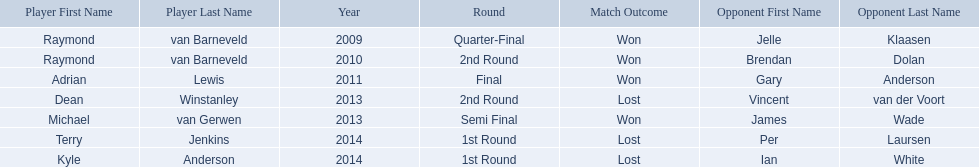What players competed in the pdc world darts championship? Raymond van Barneveld, Raymond van Barneveld, Adrian Lewis, Dean Winstanley, Michael van Gerwen, Terry Jenkins, Kyle Anderson. Of these players, who lost? Dean Winstanley, Terry Jenkins, Kyle Anderson. Which of these players lost in 2014? Terry Jenkins, Kyle Anderson. What are the players other than kyle anderson? Terry Jenkins. 